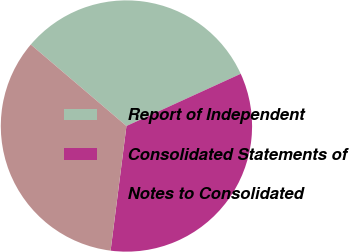<chart> <loc_0><loc_0><loc_500><loc_500><pie_chart><fcel>Report of Independent<fcel>Consolidated Statements of<fcel>Notes to Consolidated<nl><fcel>31.95%<fcel>33.83%<fcel>34.21%<nl></chart> 